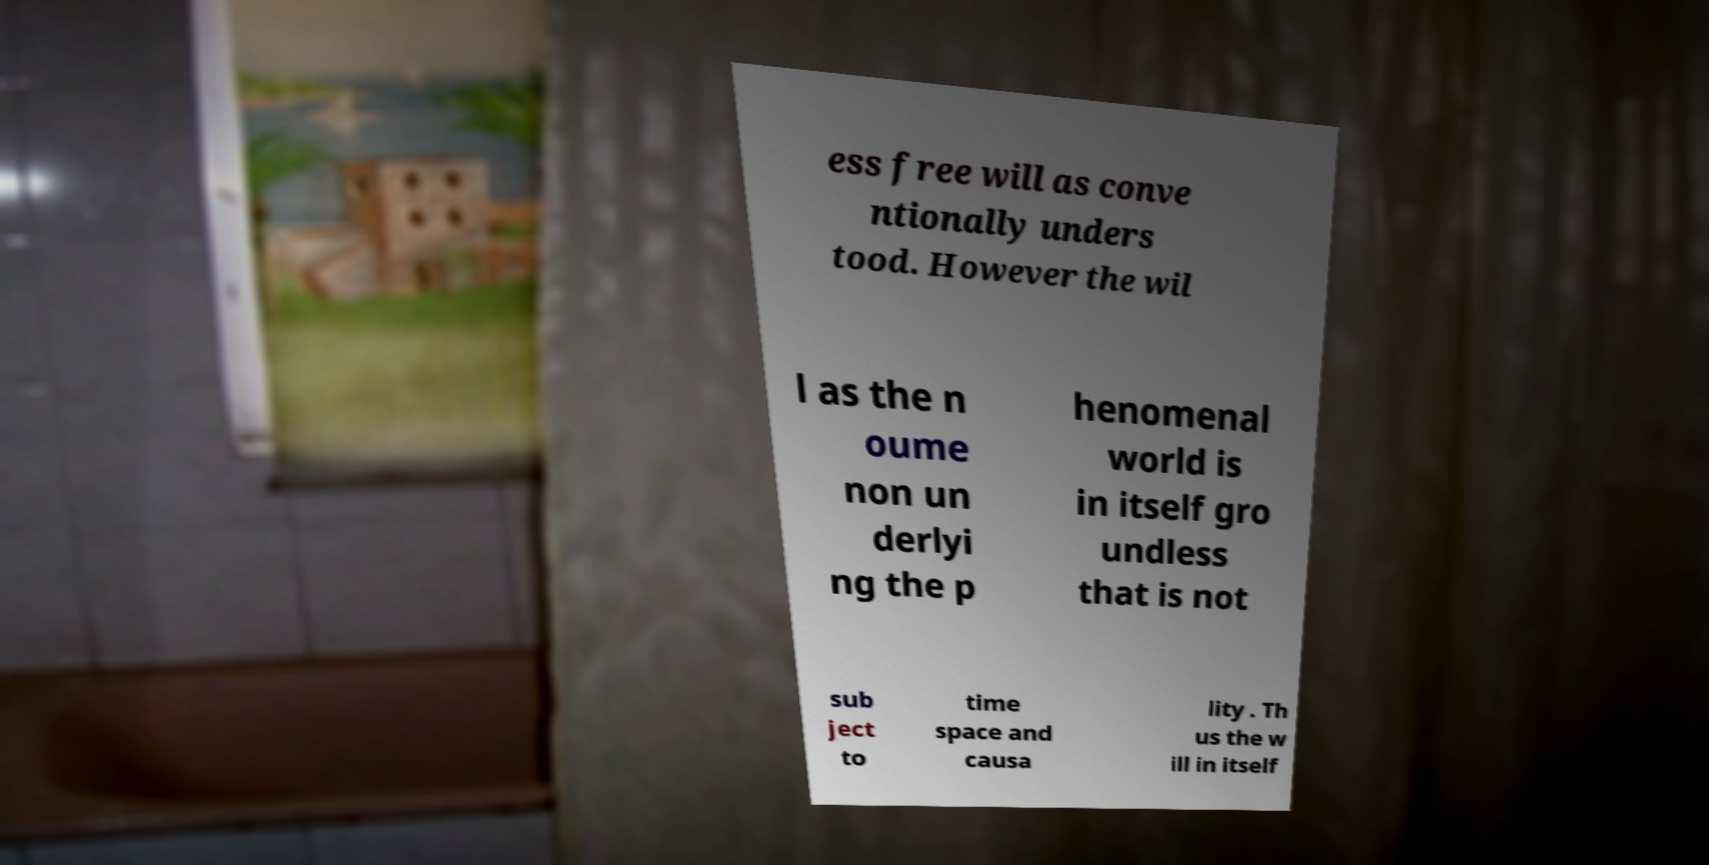What messages or text are displayed in this image? I need them in a readable, typed format. ess free will as conve ntionally unders tood. However the wil l as the n oume non un derlyi ng the p henomenal world is in itself gro undless that is not sub ject to time space and causa lity . Th us the w ill in itself 